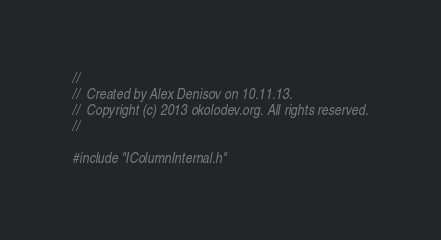<code> <loc_0><loc_0><loc_500><loc_500><_ObjectiveC_>//
//  Created by Alex Denisov on 10.11.13.
//  Copyright (c) 2013 okolodev.org. All rights reserved.
//

#include "IColumnInternal.h"
</code> 